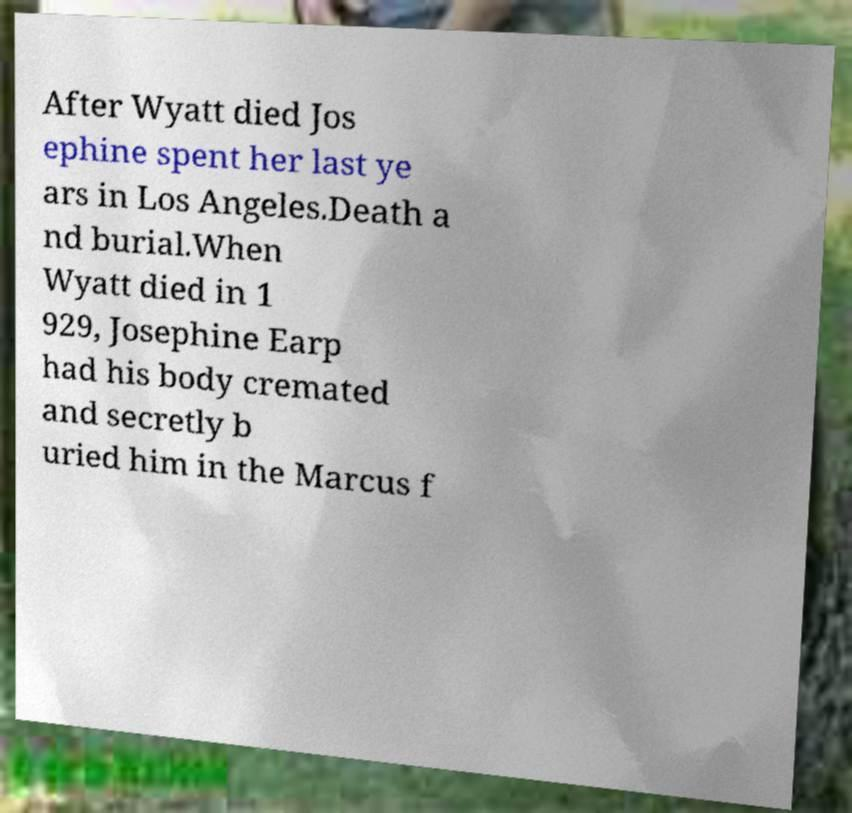What messages or text are displayed in this image? I need them in a readable, typed format. After Wyatt died Jos ephine spent her last ye ars in Los Angeles.Death a nd burial.When Wyatt died in 1 929, Josephine Earp had his body cremated and secretly b uried him in the Marcus f 